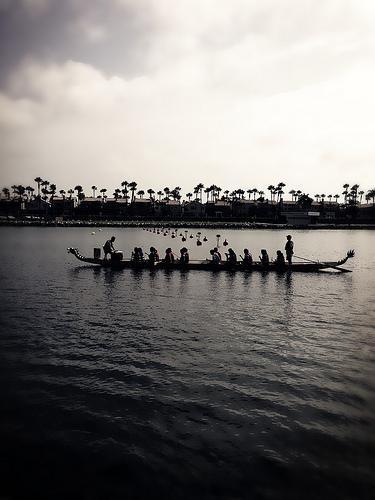How many boats are in the picture?
Give a very brief answer. 1. 